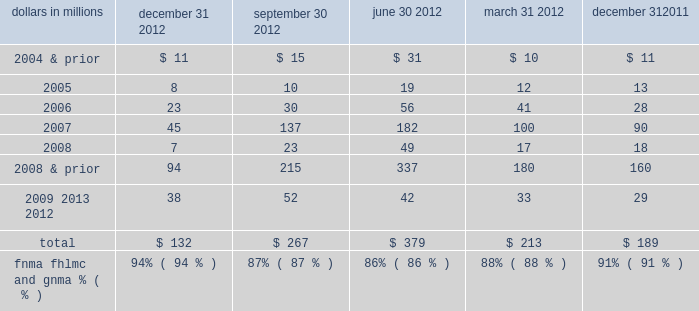Indemnification and repurchase claims are typically settled on an individual loan basis through make-whole payments or loan repurchases ; however , on occasion we may negotiate pooled settlements with investors .
In connection with pooled settlements , we typically do not repurchase loans and the consummation of such transactions generally results in us no longer having indemnification and repurchase exposure with the investor in the transaction .
For the first and second-lien mortgage balances of unresolved and settled claims contained in the tables below , a significant amount of these claims were associated with sold loans originated through correspondent lender and broker origination channels .
In certain instances when indemnification or repurchase claims are settled for these types of sold loans , we have recourse back to the correspondent lenders , brokers and other third-parties ( e.g. , contract underwriting companies , closing agents , appraisers , etc. ) .
Depending on the underlying reason for the investor claim , we determine our ability to pursue recourse with these parties and file claims with them accordingly .
Our historical recourse recovery rate has been insignificant as our efforts have been impacted by the inability of such parties to reimburse us for their recourse obligations ( e.g. , their capital availability or whether they remain in business ) or factors that limit our ability to pursue recourse from these parties ( e.g. , contractual loss caps , statutes of limitations ) .
Origination and sale of residential mortgages is an ongoing business activity , and , accordingly , management continually assesses the need to recognize indemnification and repurchase liabilities pursuant to the associated investor sale agreements .
We establish indemnification and repurchase liabilities for estimated losses on sold first and second-lien mortgages for which indemnification is expected to be provided or for loans that are expected to be repurchased .
For the first and second- lien mortgage sold portfolio , we have established an indemnification and repurchase liability pursuant to investor sale agreements based on claims made , demand patterns observed to date and/or expected in the future , and our estimate of future claims on a loan by loan basis .
To estimate the mortgage repurchase liability arising from breaches of representations and warranties , we consider the following factors : ( i ) borrower performance in our historically sold portfolio ( both actual and estimated future defaults ) , ( ii ) the level of outstanding unresolved repurchase claims , ( iii ) estimated probable future repurchase claims , considering information about file requests , delinquent and liquidated loans , resolved and unresolved mortgage insurance rescission notices and our historical experience with claim rescissions , ( iv ) the potential ability to cure the defects identified in the repurchase claims ( 201crescission rate 201d ) , and ( v ) the estimated severity of loss upon repurchase of the loan or collateral , make-whole settlement , or indemnification .
See note 24 commitments and guarantees in the notes to consolidated financial statements in item 8 of this report for additional information .
The tables present the unpaid principal balance of repurchase claims by vintage and total unresolved repurchase claims for the past five quarters .
Table 28 : analysis of quarterly residential mortgage repurchase claims by vintage dollars in millions december 31 september 30 june 30 march 31 december 31 .
The pnc financial services group , inc .
2013 form 10-k 79 .
How much in combined repurchase claims , in millions , were recorded in the first quarter of 2005 , 2006 , 2007 , 2008? 
Computations: (((12 + 41) + 100) + 17)
Answer: 170.0. 